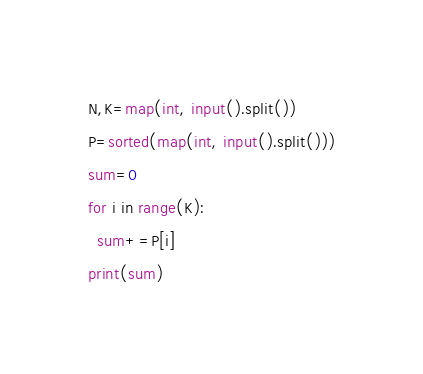<code> <loc_0><loc_0><loc_500><loc_500><_Python_>N,K=map(int, input().split())
P=sorted(map(int, input().split()))
sum=0
for i in range(K):
  sum+=P[i]
print(sum)</code> 